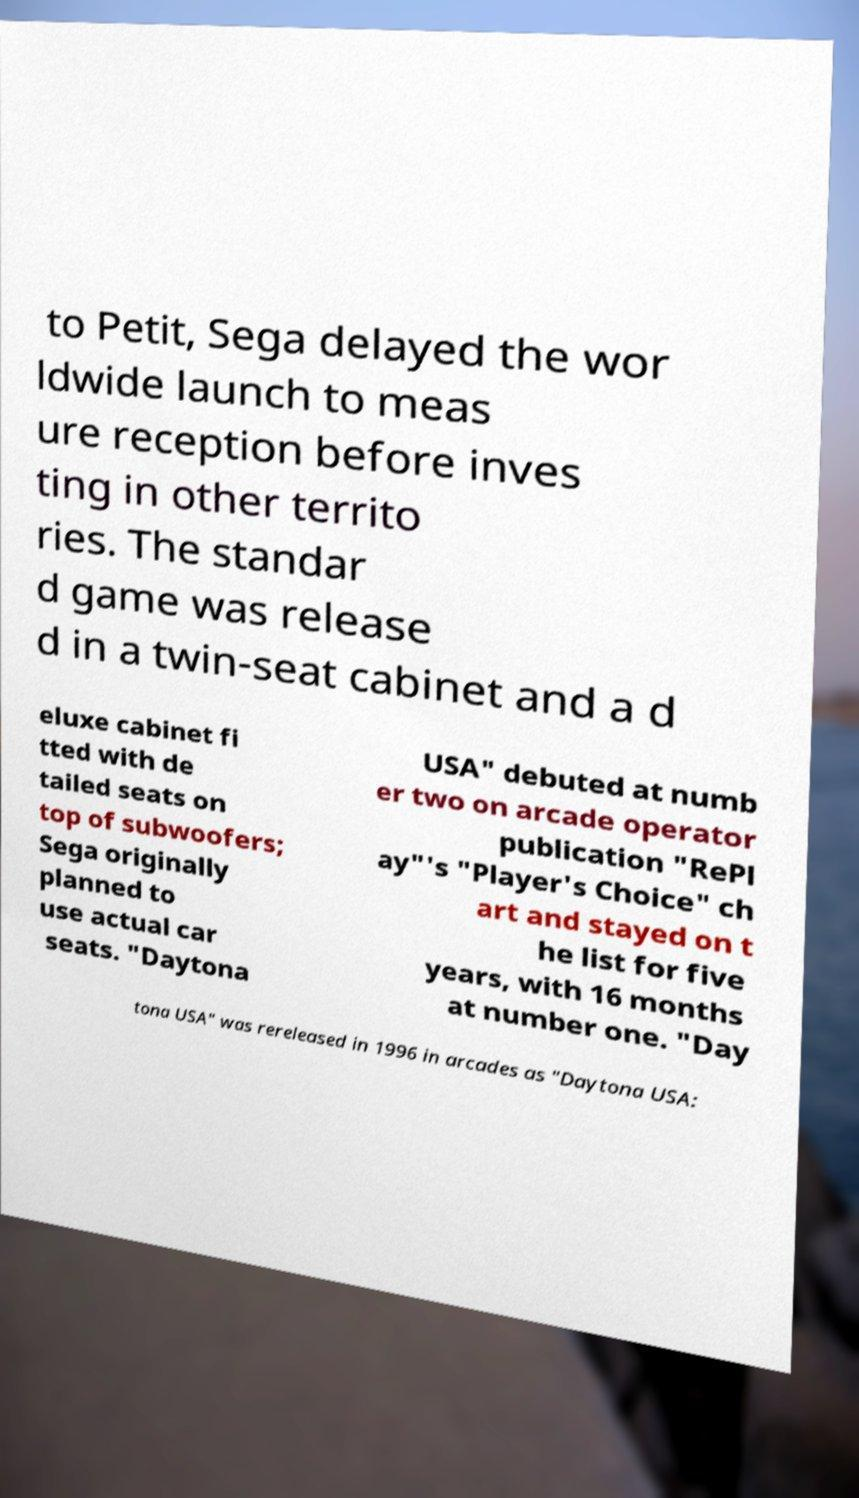I need the written content from this picture converted into text. Can you do that? to Petit, Sega delayed the wor ldwide launch to meas ure reception before inves ting in other territo ries. The standar d game was release d in a twin-seat cabinet and a d eluxe cabinet fi tted with de tailed seats on top of subwoofers; Sega originally planned to use actual car seats. "Daytona USA" debuted at numb er two on arcade operator publication "RePl ay"'s "Player's Choice" ch art and stayed on t he list for five years, with 16 months at number one. "Day tona USA" was rereleased in 1996 in arcades as "Daytona USA: 